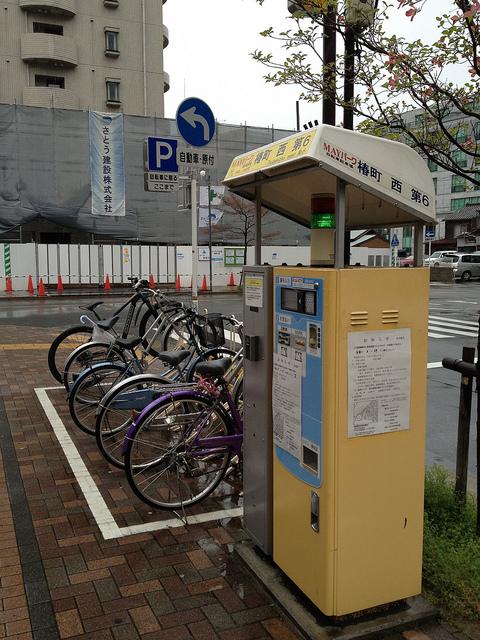Do you need to pay a fee for parking your bicycle here?
Answer briefly. Yes. Is that a parking meter near the street?
Short answer required. No. How many bicycles are there?
Answer briefly. 5. Where is the white arrow pointing?
Concise answer only. Left. What kind of business is this?
Write a very short answer. Parking lot. 